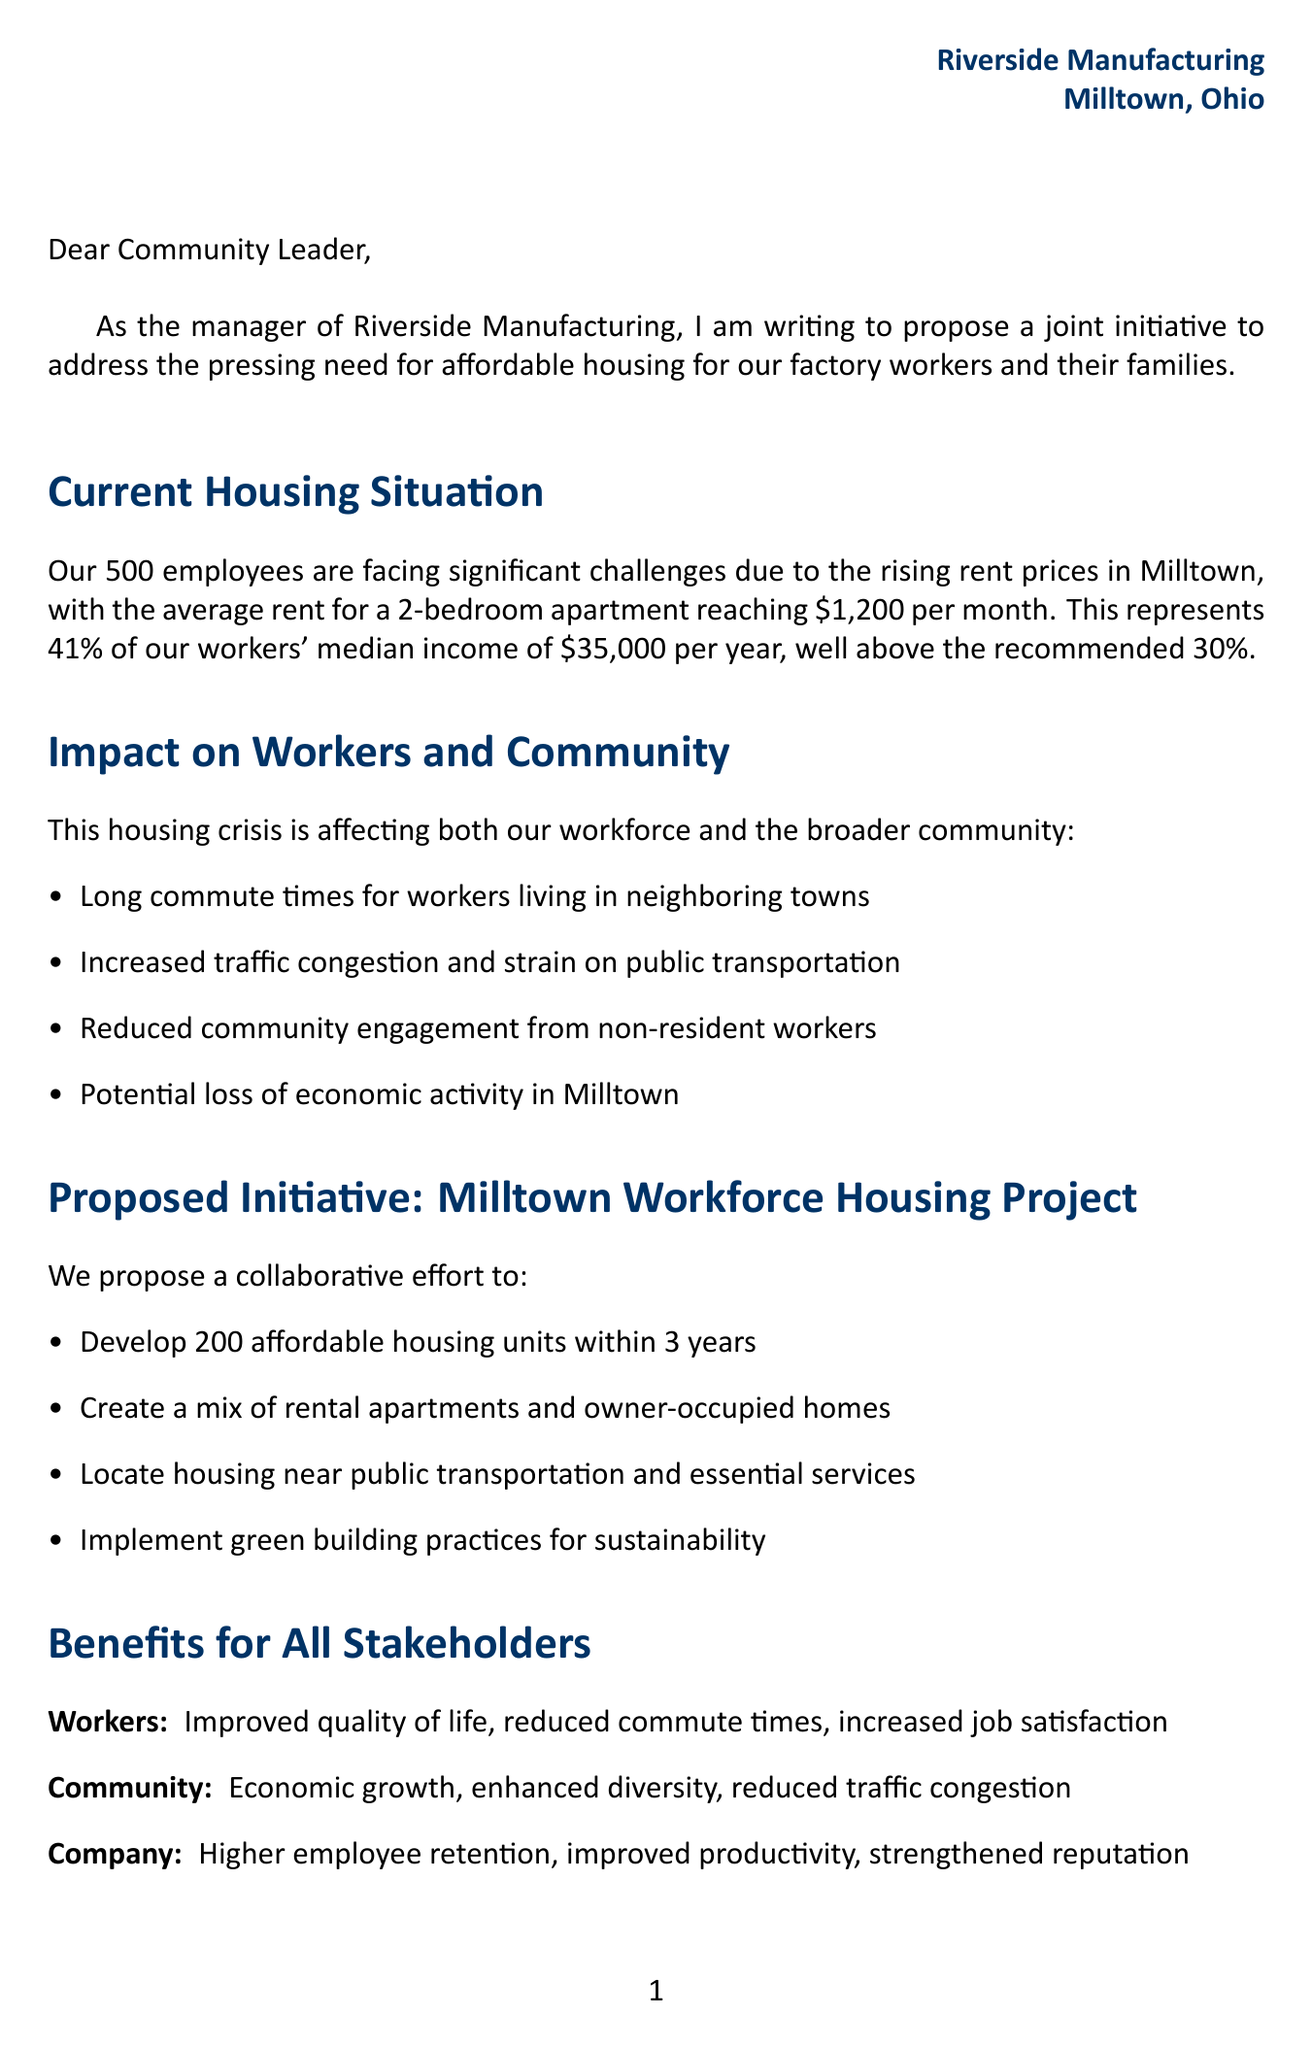What is the name of the factory? The name of the factory is mentioned in the introduction of the letter.
Answer: Riverside Manufacturing How many employees work at Riverside Manufacturing? The letter states the number of employees in the factory details section.
Answer: 500 What is the average rent for a 2-bedroom apartment in Milltown? The document provides the average rent in the section detailing current housing situations.
Answer: $1,200 What percentage of income do workers currently spend on housing? The letter specifies the percentage in the housing challenges section.
Answer: 41% What is the proposed number of affordable housing units to be developed? The proposed initiative section outlines the target number of housing units.
Answer: 200 What are the stakeholders involved in the proposed initiative? The document lists the stakeholders in the proposed initiative section.
Answer: Riverside Manufacturing, Milltown City Council, Milltown Housing Authority, Local construction companies, Community banks What is the desired percentage of income that workers should spend on housing? The housing challenges section mentions the desired percentage for a better housing situation.
Answer: 30% Which state is the proposed initiative located in? The location can be inferred from the name of the factory mentioned in the letter.
Answer: Ohio What is an example of a success story mentioned in the letter? The letter references a project to highlight the effectiveness of similar initiatives.
Answer: Greenville, South Carolina 